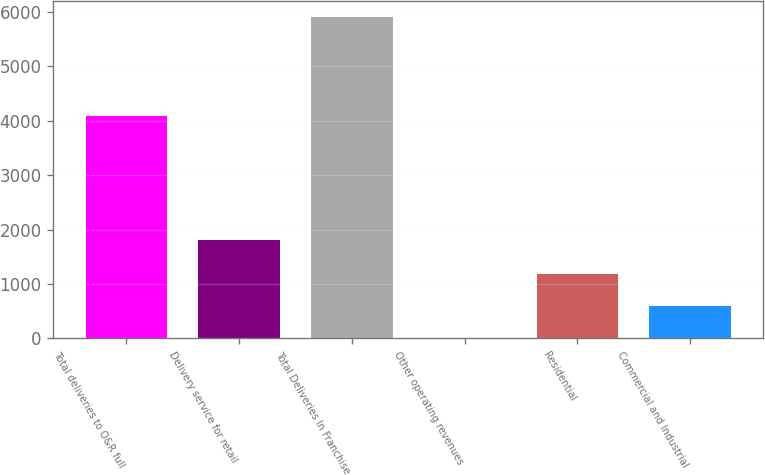Convert chart to OTSL. <chart><loc_0><loc_0><loc_500><loc_500><bar_chart><fcel>Total deliveries to O&R full<fcel>Delivery service for retail<fcel>Total Deliveries In Franchise<fcel>Other operating revenues<fcel>Residential<fcel>Commercial and Industrial<nl><fcel>4093<fcel>1814<fcel>5907<fcel>3<fcel>1183.8<fcel>593.4<nl></chart> 